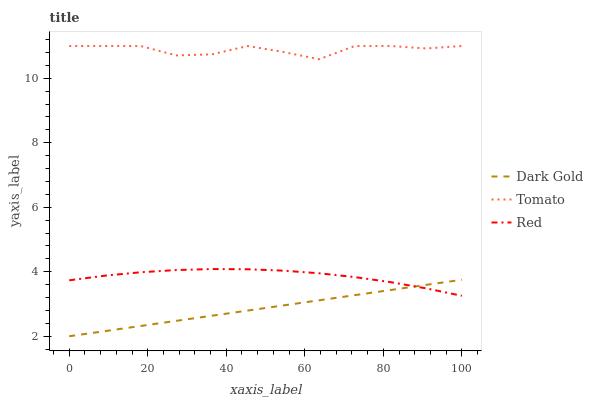Does Dark Gold have the minimum area under the curve?
Answer yes or no. Yes. Does Tomato have the maximum area under the curve?
Answer yes or no. Yes. Does Red have the minimum area under the curve?
Answer yes or no. No. Does Red have the maximum area under the curve?
Answer yes or no. No. Is Dark Gold the smoothest?
Answer yes or no. Yes. Is Tomato the roughest?
Answer yes or no. Yes. Is Red the smoothest?
Answer yes or no. No. Is Red the roughest?
Answer yes or no. No. Does Red have the lowest value?
Answer yes or no. No. Does Tomato have the highest value?
Answer yes or no. Yes. Does Red have the highest value?
Answer yes or no. No. Is Dark Gold less than Tomato?
Answer yes or no. Yes. Is Tomato greater than Dark Gold?
Answer yes or no. Yes. Does Dark Gold intersect Red?
Answer yes or no. Yes. Is Dark Gold less than Red?
Answer yes or no. No. Is Dark Gold greater than Red?
Answer yes or no. No. Does Dark Gold intersect Tomato?
Answer yes or no. No. 